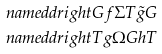Convert formula to latex. <formula><loc_0><loc_0><loc_500><loc_500>& \ n a m e d d r i g h t { G } { f } { \Sigma T } { \tilde { g } } { G } \\ & \ n a m e d d r i g h t { T } { g } { \Omega G } { h } { T }</formula> 